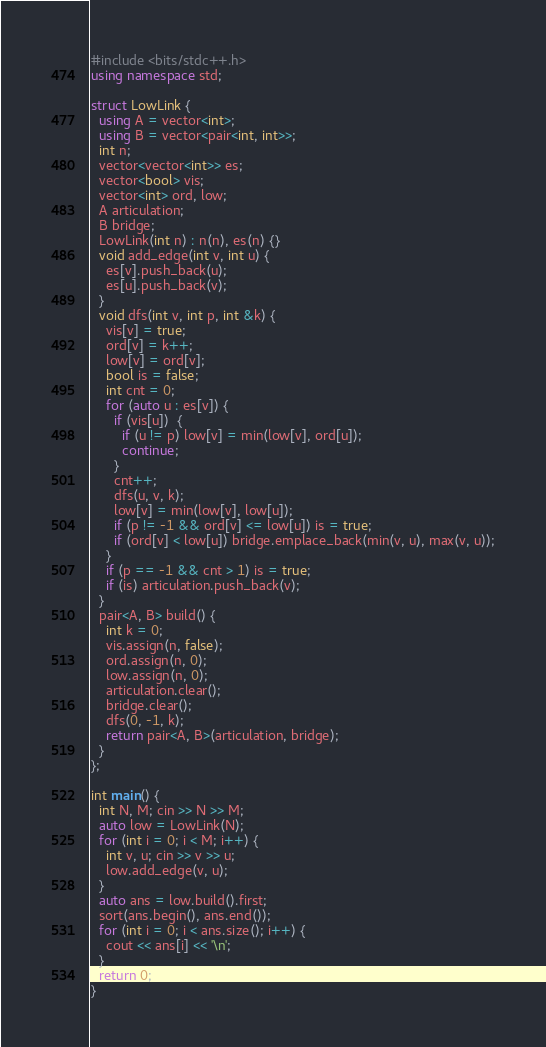<code> <loc_0><loc_0><loc_500><loc_500><_C++_>#include <bits/stdc++.h>
using namespace std;

struct LowLink {
  using A = vector<int>;
  using B = vector<pair<int, int>>;
  int n;
  vector<vector<int>> es;
  vector<bool> vis;
  vector<int> ord, low;
  A articulation;
  B bridge;
  LowLink(int n) : n(n), es(n) {}
  void add_edge(int v, int u) {
    es[v].push_back(u);
    es[u].push_back(v);
  }
  void dfs(int v, int p, int &k) {
    vis[v] = true;
    ord[v] = k++;
    low[v] = ord[v];
    bool is = false;
    int cnt = 0;
    for (auto u : es[v]) {
      if (vis[u])  {
        if (u != p) low[v] = min(low[v], ord[u]);
        continue;
      }
      cnt++;
      dfs(u, v, k);
      low[v] = min(low[v], low[u]);
      if (p != -1 && ord[v] <= low[u]) is = true;
      if (ord[v] < low[u]) bridge.emplace_back(min(v, u), max(v, u));
    }
    if (p == -1 && cnt > 1) is = true;
    if (is) articulation.push_back(v);
  }
  pair<A, B> build() {
    int k = 0;
    vis.assign(n, false);
    ord.assign(n, 0);
    low.assign(n, 0);
    articulation.clear();
    bridge.clear();
    dfs(0, -1, k);
    return pair<A, B>(articulation, bridge);
  }
};

int main() {
  int N, M; cin >> N >> M;
  auto low = LowLink(N);
  for (int i = 0; i < M; i++) {
    int v, u; cin >> v >> u;
    low.add_edge(v, u);
  }
  auto ans = low.build().first;
  sort(ans.begin(), ans.end());
  for (int i = 0; i < ans.size(); i++) {
    cout << ans[i] << '\n';
  }
  return 0;
}

</code> 